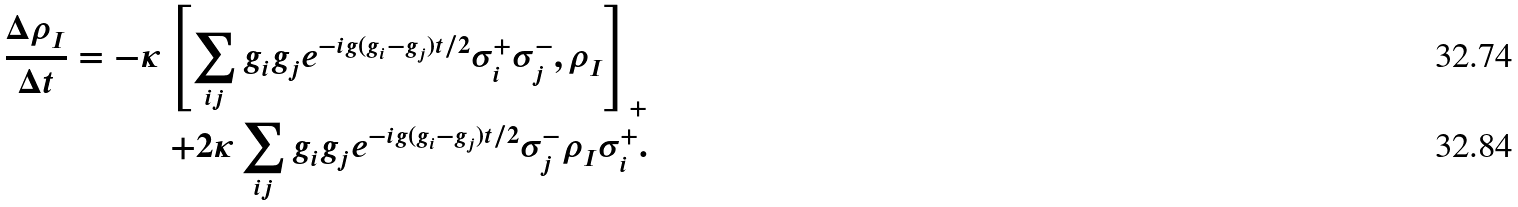<formula> <loc_0><loc_0><loc_500><loc_500>\frac { \Delta \rho _ { I } } { \Delta t } = - \kappa \left [ \sum _ { i j } g _ { i } g _ { j } e ^ { - i g ( g _ { i } - g _ { j } ) t / 2 } \sigma _ { i } ^ { + } \sigma _ { j } ^ { - } , \rho _ { I } \right ] _ { + } \\ + 2 \kappa \sum _ { i j } g _ { i } g _ { j } e ^ { - i g ( g _ { i } - g _ { j } ) t / 2 } \sigma _ { j } ^ { - } \rho _ { I } \sigma _ { i } ^ { + } .</formula> 